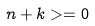Convert formula to latex. <formula><loc_0><loc_0><loc_500><loc_500>n + k > = 0</formula> 